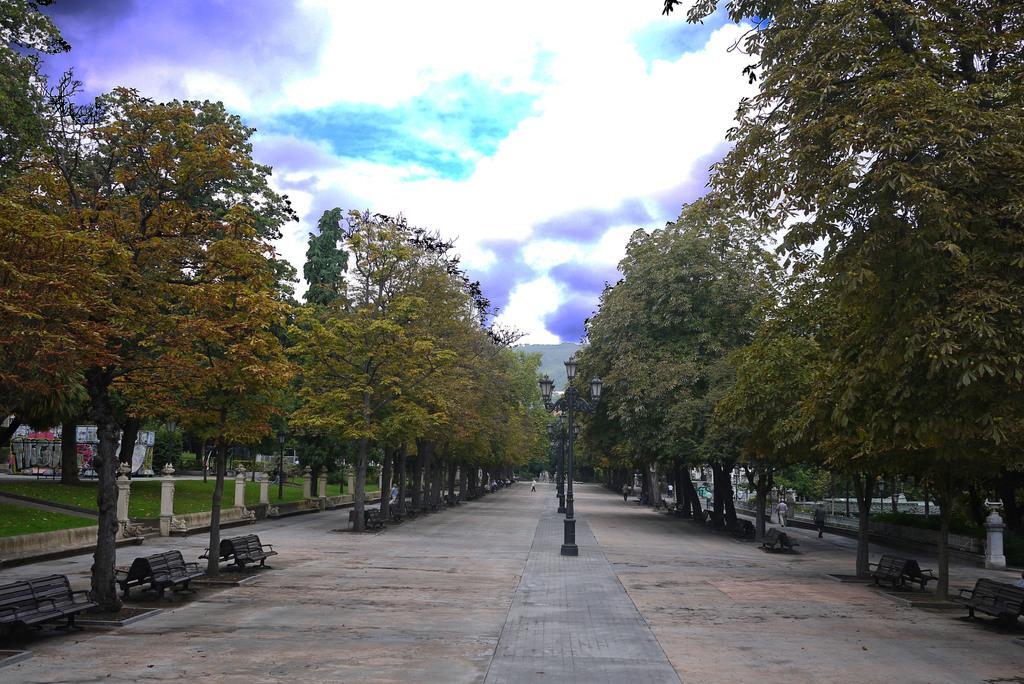In one or two sentences, can you explain what this image depicts? In the foreground of this image, there is a path, few poles and on either side, there are benches, trees and greenery. At the top, there is the sky. 